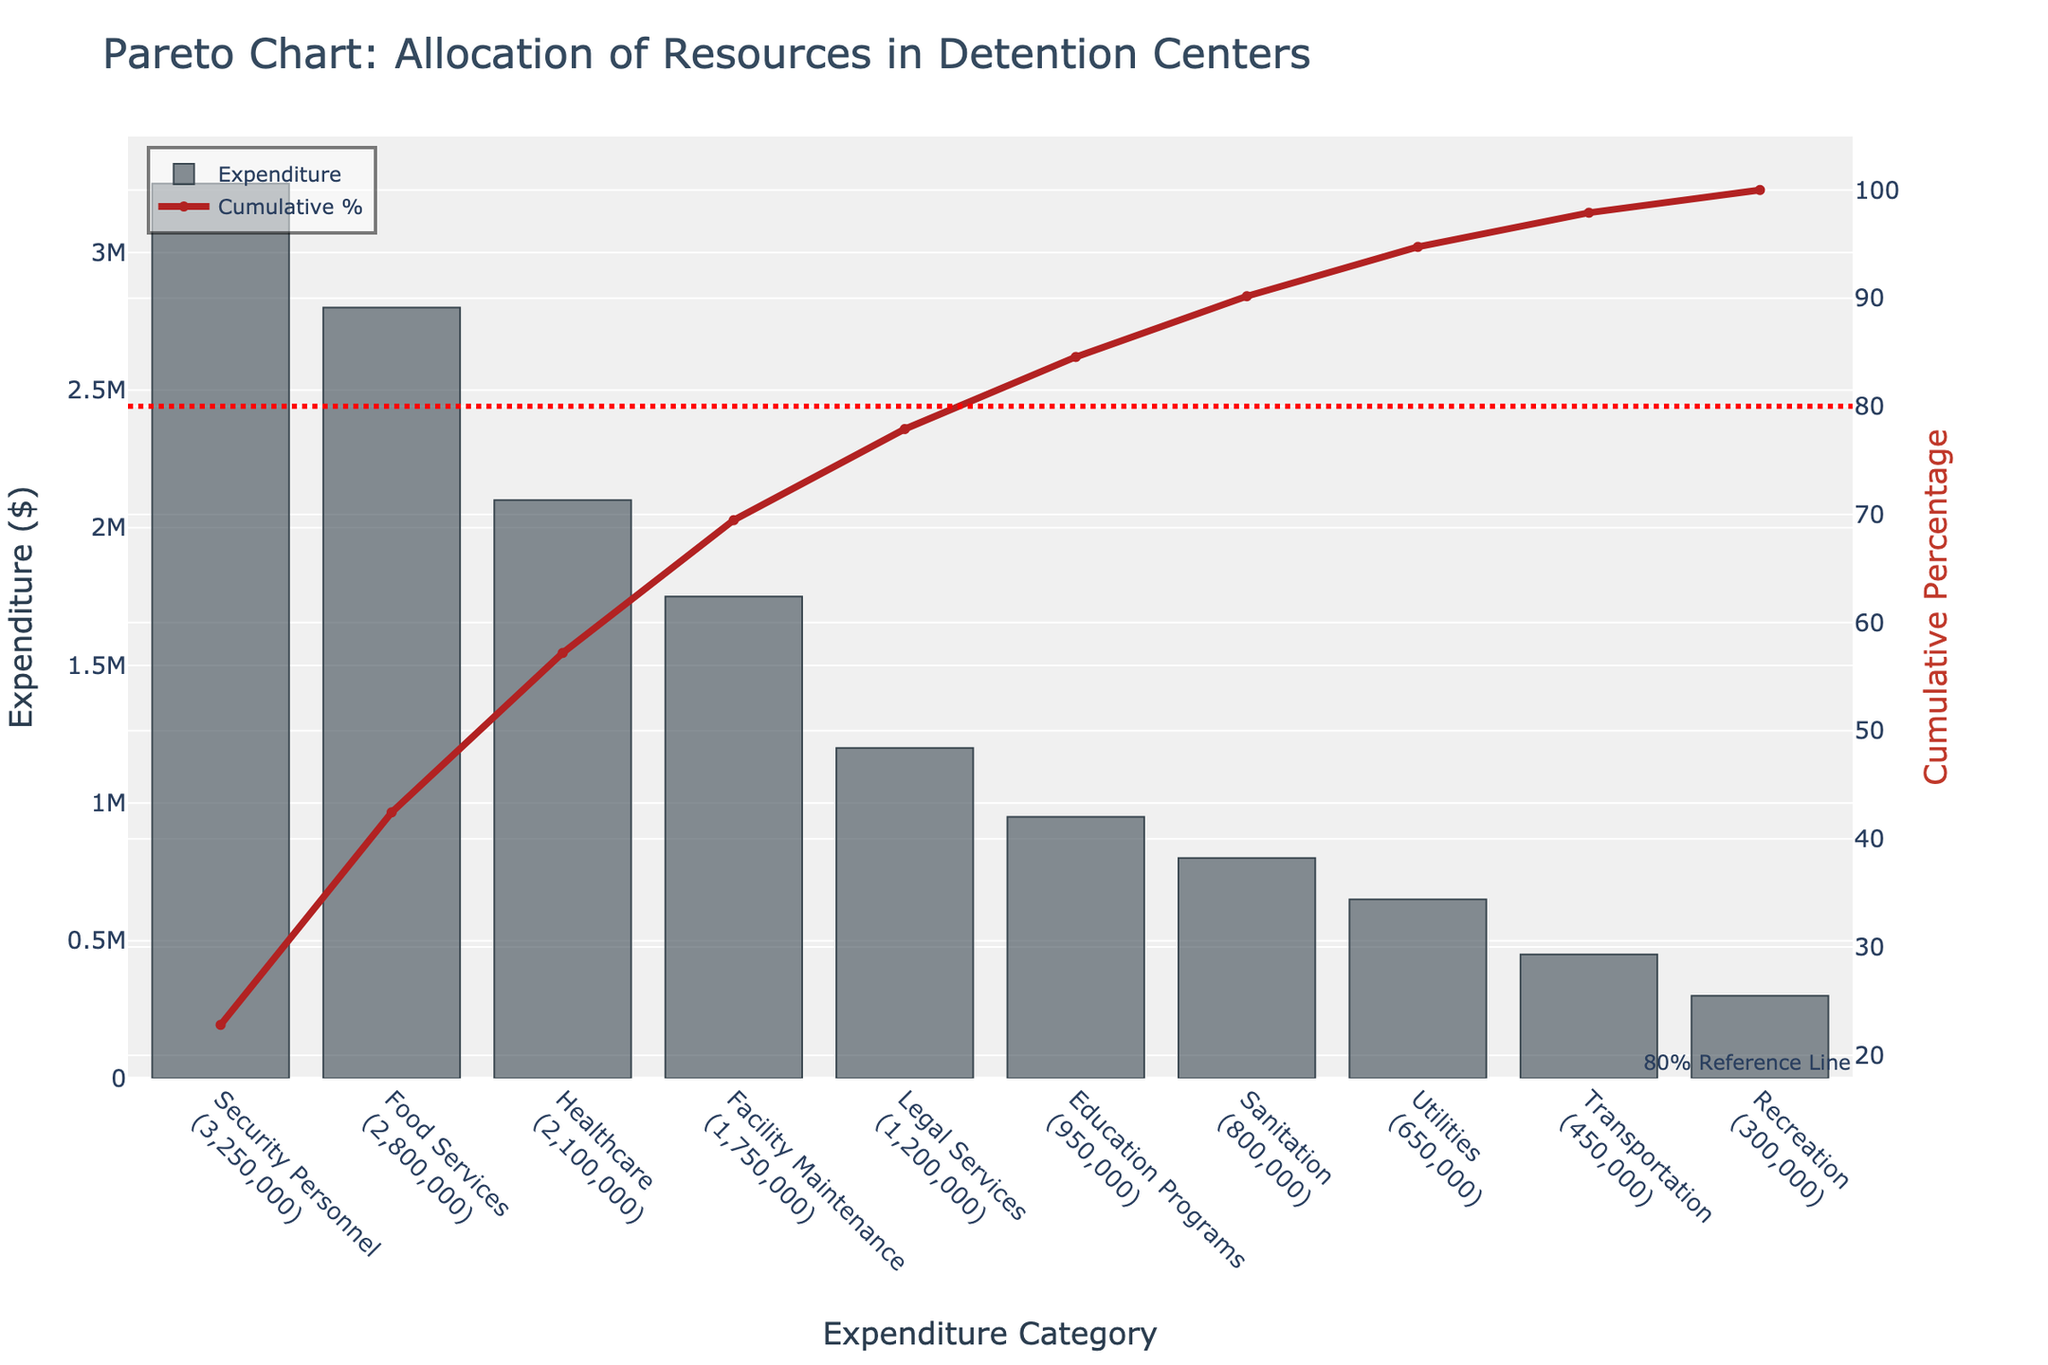What's the title of the chart? The title of the chart is at the top, displaying "Pareto Chart: Allocation of Resources in Detention Centers."
Answer: Pareto Chart: Allocation of Resources in Detention Centers What is the category with the highest expenditure? The category with the highest expenditure is the first bar on the left of the bar chart, which represents "Security Personnel"
Answer: Security Personnel What is the cumulative percentage at the category "Healthcare"? Locate the "Healthcare" category on the x-axis and follow its corresponding point on the red cumulative percentage line. The cumulative percentage for "Healthcare" is around 67%.
Answer: 67% What is the combined expenditure for "Food Services" and "Healthcare"? Identify the expenditures for "Food Services" ($2,800,000) and "Healthcare" ($2,100,000) on the y-axis and add them up: $2,800,000 + $2,100,000 = $4,900,000.
Answer: $4,900,000 How many categories do you need to reach the 80% cumulative percentage? Observe the red cumulative percentage line and follow until it hits 80%. This occurs after the category "Legal Services," which means you need five categories: "Security Personnel," "Food Services," "Healthcare," "Facility Maintenance," and "Legal Services."
Answer: 5 Which category has the lowest expenditure? The category with the lowest expenditure is the last bar on the right side, which is "Recreation."
Answer: Recreation How does the expenditure for "Transportation" compare to "Sanitation"? Locate the bars for "Transportation" ($450,000) and "Sanitation" ($800,000). The expenditure for "Transportation" is less than "Sanitation."
Answer: Less What percentage of total expenditure is made up by the first three categories? Add the expenses for "Security Personnel" ($3,250,000), "Food Services" ($2,800,000), and "Healthcare" ($2,100,000). The total is $8,150,000. Calculate the percentage, $8,150,000 / total expenditure * 100 ($11,800,000 being total). The result is approximately 69%.
Answer: 69% What is the color of the bar representing "Education Programs"? The bar color for "Education Programs" is a shade of gray.
Answer: Gray 